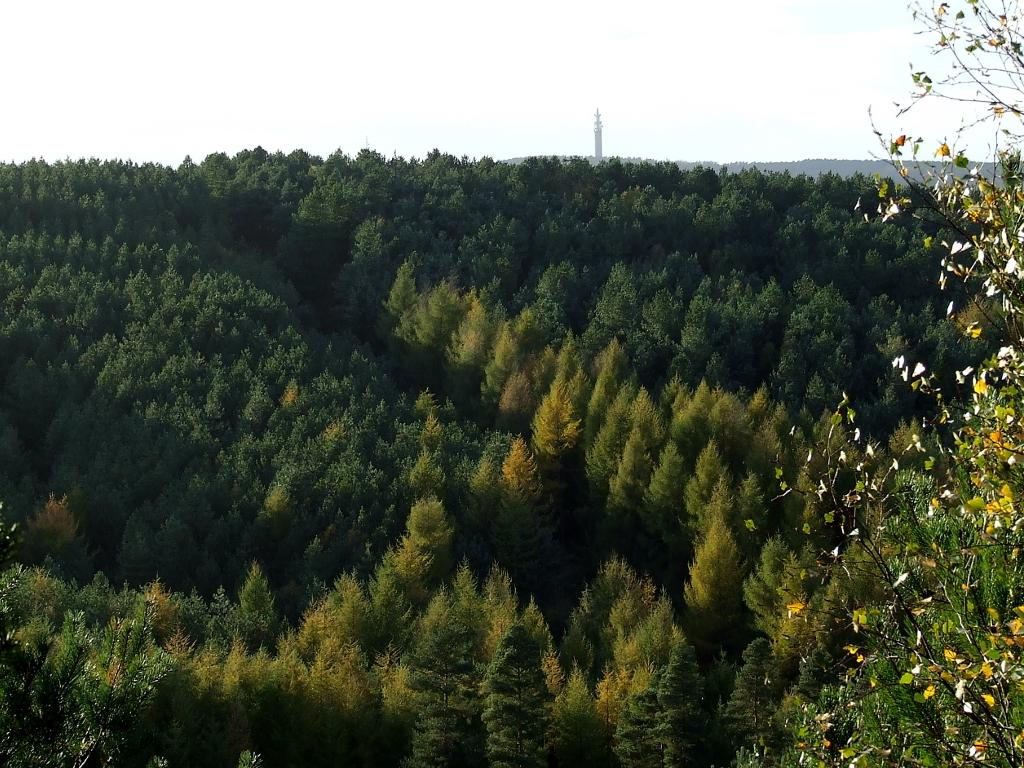What type of vegetation can be seen in the image? There are trees in the image. What colors are the trees in the image? The trees are green and yellow in color. What structure is visible in the background of the image? There is a huge tower in the background of the image. What else can be seen in the background of the image? The sky is visible in the background of the image. What type of truck is being discussed in the image? There is no truck present in the image, and no discussion is taking place. 